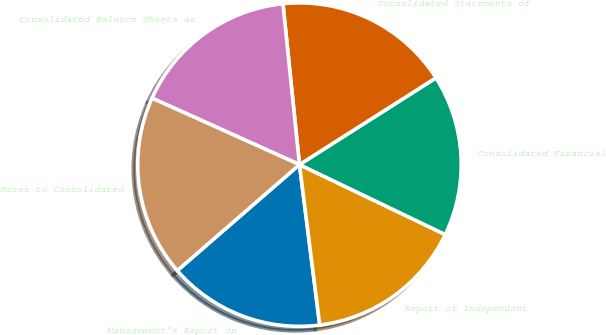Convert chart to OTSL. <chart><loc_0><loc_0><loc_500><loc_500><pie_chart><fcel>Management's Report on<fcel>Report of Independent<fcel>Consolidated Financial<fcel>Consolidated Statements of<fcel>Consolidated Balance Sheets as<fcel>Notes to Consolidated<nl><fcel>15.63%<fcel>15.88%<fcel>16.13%<fcel>17.62%<fcel>16.63%<fcel>18.11%<nl></chart> 